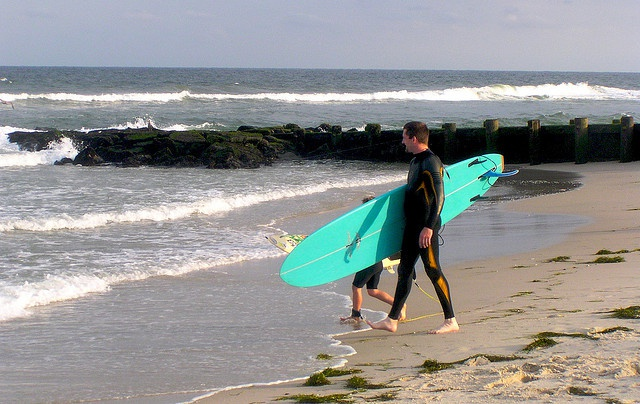Describe the objects in this image and their specific colors. I can see surfboard in lavender, turquoise, teal, and black tones, people in lavender, black, darkgray, gray, and maroon tones, people in lavender, black, brown, and tan tones, and surfboard in lavender, khaki, beige, darkgray, and black tones in this image. 